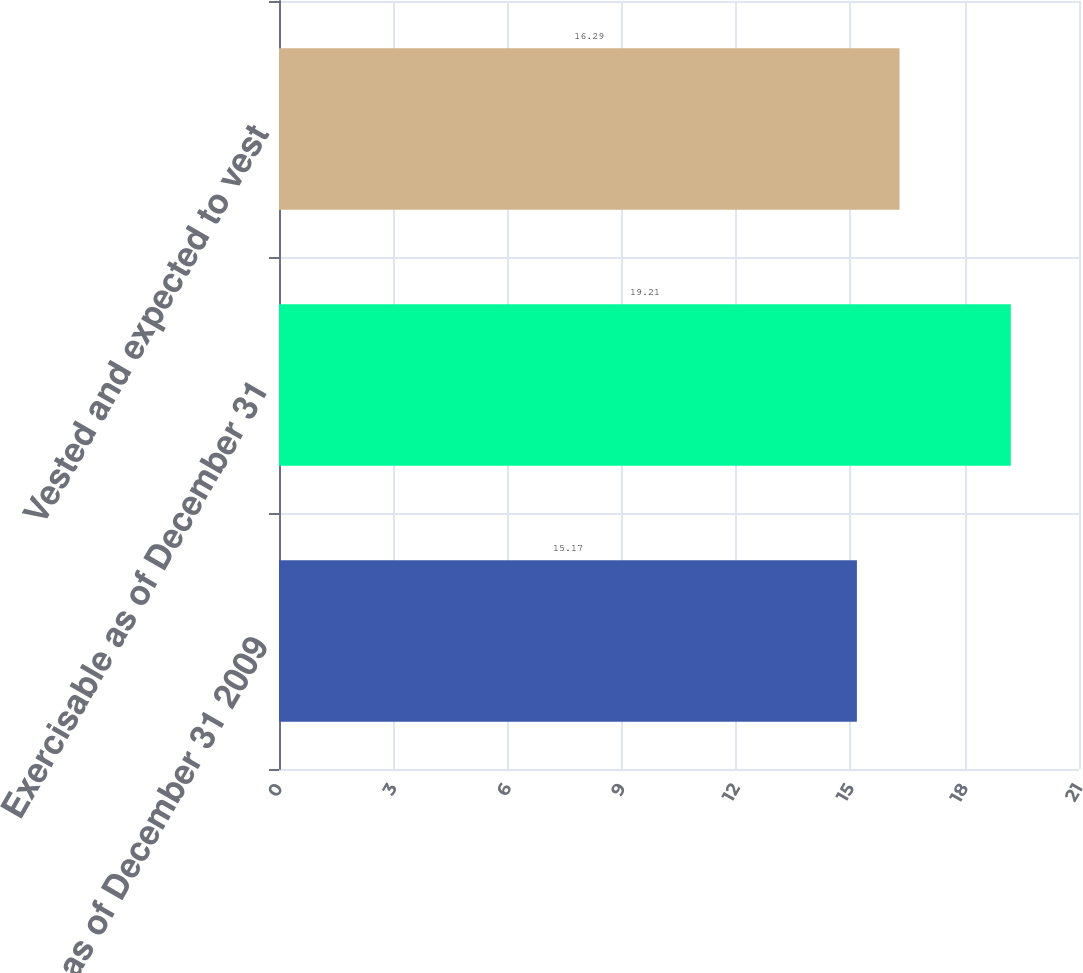<chart> <loc_0><loc_0><loc_500><loc_500><bar_chart><fcel>Balance as of December 31 2009<fcel>Exercisable as of December 31<fcel>Vested and expected to vest<nl><fcel>15.17<fcel>19.21<fcel>16.29<nl></chart> 